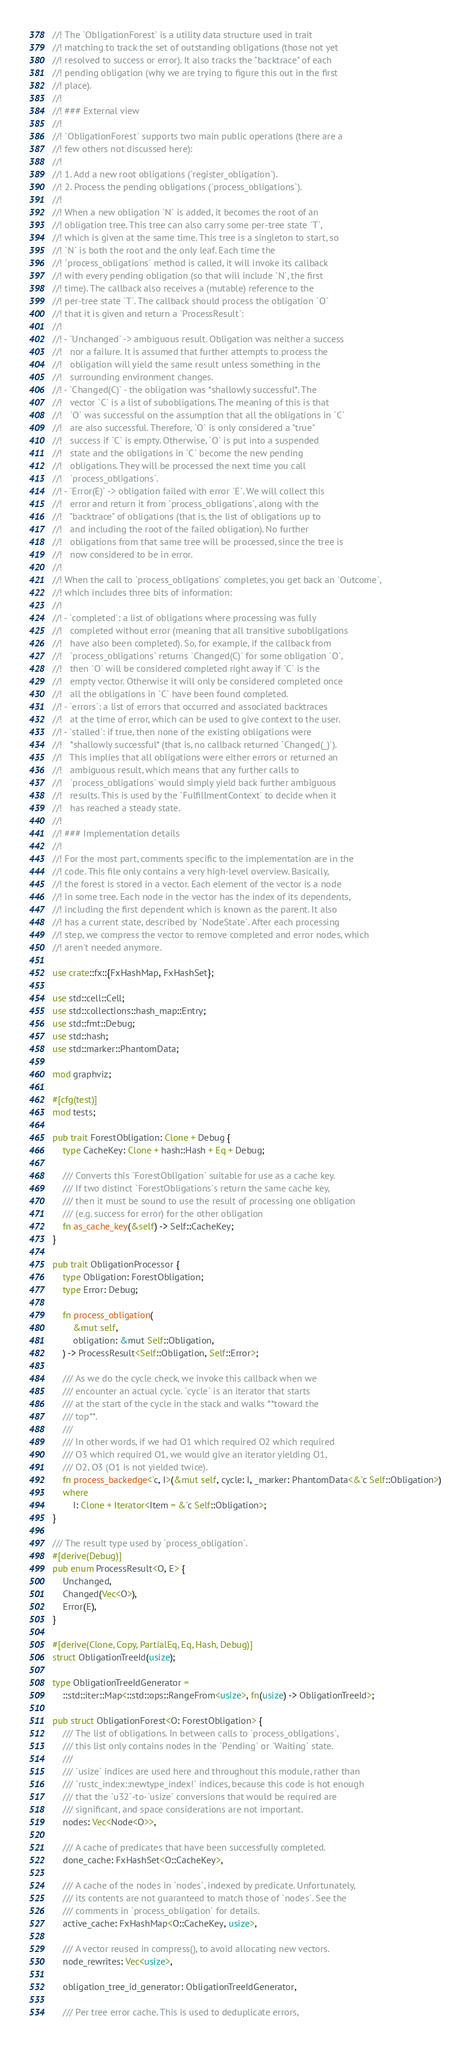<code> <loc_0><loc_0><loc_500><loc_500><_Rust_>//! The `ObligationForest` is a utility data structure used in trait
//! matching to track the set of outstanding obligations (those not yet
//! resolved to success or error). It also tracks the "backtrace" of each
//! pending obligation (why we are trying to figure this out in the first
//! place).
//!
//! ### External view
//!
//! `ObligationForest` supports two main public operations (there are a
//! few others not discussed here):
//!
//! 1. Add a new root obligations (`register_obligation`).
//! 2. Process the pending obligations (`process_obligations`).
//!
//! When a new obligation `N` is added, it becomes the root of an
//! obligation tree. This tree can also carry some per-tree state `T`,
//! which is given at the same time. This tree is a singleton to start, so
//! `N` is both the root and the only leaf. Each time the
//! `process_obligations` method is called, it will invoke its callback
//! with every pending obligation (so that will include `N`, the first
//! time). The callback also receives a (mutable) reference to the
//! per-tree state `T`. The callback should process the obligation `O`
//! that it is given and return a `ProcessResult`:
//!
//! - `Unchanged` -> ambiguous result. Obligation was neither a success
//!   nor a failure. It is assumed that further attempts to process the
//!   obligation will yield the same result unless something in the
//!   surrounding environment changes.
//! - `Changed(C)` - the obligation was *shallowly successful*. The
//!   vector `C` is a list of subobligations. The meaning of this is that
//!   `O` was successful on the assumption that all the obligations in `C`
//!   are also successful. Therefore, `O` is only considered a "true"
//!   success if `C` is empty. Otherwise, `O` is put into a suspended
//!   state and the obligations in `C` become the new pending
//!   obligations. They will be processed the next time you call
//!   `process_obligations`.
//! - `Error(E)` -> obligation failed with error `E`. We will collect this
//!   error and return it from `process_obligations`, along with the
//!   "backtrace" of obligations (that is, the list of obligations up to
//!   and including the root of the failed obligation). No further
//!   obligations from that same tree will be processed, since the tree is
//!   now considered to be in error.
//!
//! When the call to `process_obligations` completes, you get back an `Outcome`,
//! which includes three bits of information:
//!
//! - `completed`: a list of obligations where processing was fully
//!   completed without error (meaning that all transitive subobligations
//!   have also been completed). So, for example, if the callback from
//!   `process_obligations` returns `Changed(C)` for some obligation `O`,
//!   then `O` will be considered completed right away if `C` is the
//!   empty vector. Otherwise it will only be considered completed once
//!   all the obligations in `C` have been found completed.
//! - `errors`: a list of errors that occurred and associated backtraces
//!   at the time of error, which can be used to give context to the user.
//! - `stalled`: if true, then none of the existing obligations were
//!   *shallowly successful* (that is, no callback returned `Changed(_)`).
//!   This implies that all obligations were either errors or returned an
//!   ambiguous result, which means that any further calls to
//!   `process_obligations` would simply yield back further ambiguous
//!   results. This is used by the `FulfillmentContext` to decide when it
//!   has reached a steady state.
//!
//! ### Implementation details
//!
//! For the most part, comments specific to the implementation are in the
//! code. This file only contains a very high-level overview. Basically,
//! the forest is stored in a vector. Each element of the vector is a node
//! in some tree. Each node in the vector has the index of its dependents,
//! including the first dependent which is known as the parent. It also
//! has a current state, described by `NodeState`. After each processing
//! step, we compress the vector to remove completed and error nodes, which
//! aren't needed anymore.

use crate::fx::{FxHashMap, FxHashSet};

use std::cell::Cell;
use std::collections::hash_map::Entry;
use std::fmt::Debug;
use std::hash;
use std::marker::PhantomData;

mod graphviz;

#[cfg(test)]
mod tests;

pub trait ForestObligation: Clone + Debug {
    type CacheKey: Clone + hash::Hash + Eq + Debug;

    /// Converts this `ForestObligation` suitable for use as a cache key.
    /// If two distinct `ForestObligations`s return the same cache key,
    /// then it must be sound to use the result of processing one obligation
    /// (e.g. success for error) for the other obligation
    fn as_cache_key(&self) -> Self::CacheKey;
}

pub trait ObligationProcessor {
    type Obligation: ForestObligation;
    type Error: Debug;

    fn process_obligation(
        &mut self,
        obligation: &mut Self::Obligation,
    ) -> ProcessResult<Self::Obligation, Self::Error>;

    /// As we do the cycle check, we invoke this callback when we
    /// encounter an actual cycle. `cycle` is an iterator that starts
    /// at the start of the cycle in the stack and walks **toward the
    /// top**.
    ///
    /// In other words, if we had O1 which required O2 which required
    /// O3 which required O1, we would give an iterator yielding O1,
    /// O2, O3 (O1 is not yielded twice).
    fn process_backedge<'c, I>(&mut self, cycle: I, _marker: PhantomData<&'c Self::Obligation>)
    where
        I: Clone + Iterator<Item = &'c Self::Obligation>;
}

/// The result type used by `process_obligation`.
#[derive(Debug)]
pub enum ProcessResult<O, E> {
    Unchanged,
    Changed(Vec<O>),
    Error(E),
}

#[derive(Clone, Copy, PartialEq, Eq, Hash, Debug)]
struct ObligationTreeId(usize);

type ObligationTreeIdGenerator =
    ::std::iter::Map<::std::ops::RangeFrom<usize>, fn(usize) -> ObligationTreeId>;

pub struct ObligationForest<O: ForestObligation> {
    /// The list of obligations. In between calls to `process_obligations`,
    /// this list only contains nodes in the `Pending` or `Waiting` state.
    ///
    /// `usize` indices are used here and throughout this module, rather than
    /// `rustc_index::newtype_index!` indices, because this code is hot enough
    /// that the `u32`-to-`usize` conversions that would be required are
    /// significant, and space considerations are not important.
    nodes: Vec<Node<O>>,

    /// A cache of predicates that have been successfully completed.
    done_cache: FxHashSet<O::CacheKey>,

    /// A cache of the nodes in `nodes`, indexed by predicate. Unfortunately,
    /// its contents are not guaranteed to match those of `nodes`. See the
    /// comments in `process_obligation` for details.
    active_cache: FxHashMap<O::CacheKey, usize>,

    /// A vector reused in compress(), to avoid allocating new vectors.
    node_rewrites: Vec<usize>,

    obligation_tree_id_generator: ObligationTreeIdGenerator,

    /// Per tree error cache. This is used to deduplicate errors,</code> 